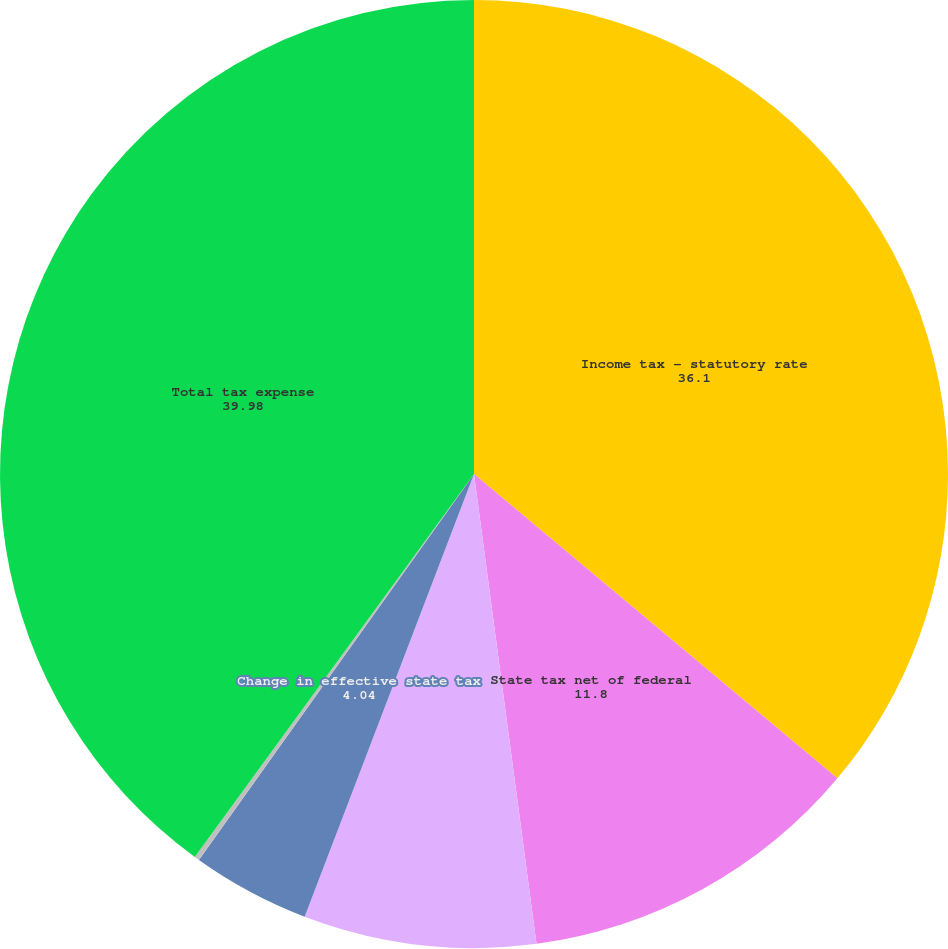<chart> <loc_0><loc_0><loc_500><loc_500><pie_chart><fcel>Income tax - statutory rate<fcel>State tax net of federal<fcel>Nondeductible meals and<fcel>Change in effective state tax<fcel>Other net<fcel>Total tax expense<nl><fcel>36.1%<fcel>11.8%<fcel>7.92%<fcel>4.04%<fcel>0.17%<fcel>39.98%<nl></chart> 